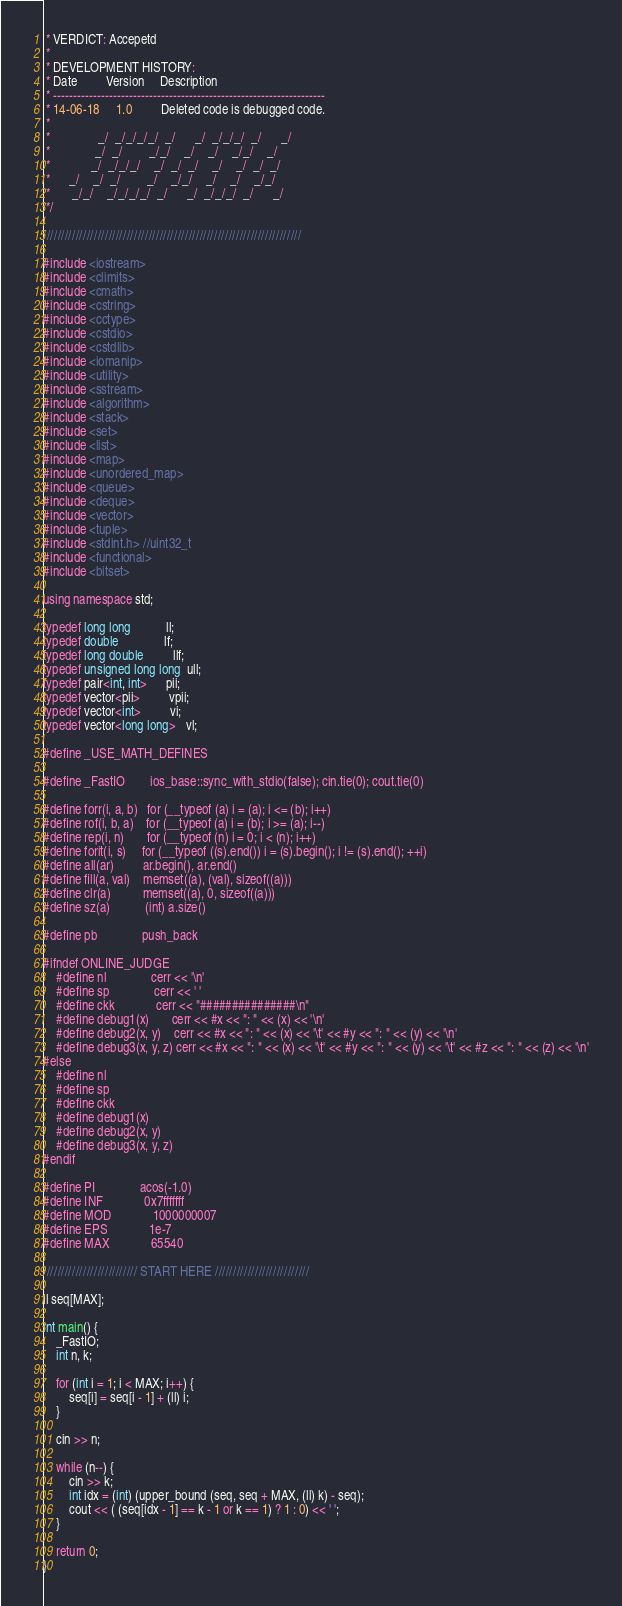<code> <loc_0><loc_0><loc_500><loc_500><_C++_> * VERDICT: Accepetd
 *
 * DEVELOPMENT HISTORY:
 * Date         Version     Description
 * --------------------------------------------------------------------
 * 14-06-18     1.0         Deleted code is debugged code.
 *
 *               _/  _/_/_/_/  _/      _/  _/_/_/  _/      _/
 *              _/  _/        _/_/    _/    _/    _/_/    _/
 *             _/  _/_/_/    _/  _/  _/    _/    _/  _/  _/
 *      _/    _/  _/        _/    _/_/    _/    _/    _/_/
 *       _/_/    _/_/_/_/  _/      _/  _/_/_/  _/      _/
 */

///////////////////////////////////////////////////////////////////////

#include <iostream>
#include <climits>
#include <cmath>
#include <cstring>
#include <cctype>
#include <cstdio>
#include <cstdlib>
#include <iomanip>
#include <utility>
#include <sstream>
#include <algorithm>
#include <stack>
#include <set>
#include <list>
#include <map>
#include <unordered_map>
#include <queue>
#include <deque>
#include <vector>
#include <tuple>
#include <stdint.h> //uint32_t
#include <functional>
#include <bitset>

using namespace std;

typedef long long           ll;
typedef double              lf;
typedef long double         llf;
typedef unsigned long long  ull;
typedef pair<int, int>      pii;
typedef vector<pii>         vpii;
typedef vector<int>         vi;
typedef vector<long long>   vl;

#define _USE_MATH_DEFINES

#define _FastIO        ios_base::sync_with_stdio(false); cin.tie(0); cout.tie(0)

#define forr(i, a, b)   for (__typeof (a) i = (a); i <= (b); i++)
#define rof(i, b, a)    for (__typeof (a) i = (b); i >= (a); i--)
#define rep(i, n)       for (__typeof (n) i = 0; i < (n); i++)
#define forit(i, s)     for (__typeof ((s).end()) i = (s).begin(); i != (s).end(); ++i)
#define all(ar)         ar.begin(), ar.end()
#define fill(a, val)    memset((a), (val), sizeof((a)))
#define clr(a)          memset((a), 0, sizeof((a)))
#define sz(a)           (int) a.size()

#define pb              push_back

#ifndef ONLINE_JUDGE
    #define nl              cerr << '\n'
    #define sp              cerr << ' '
    #define ckk             cerr << "###############\n"
    #define debug1(x)       cerr << #x << ": " << (x) << '\n'
    #define debug2(x, y)    cerr << #x << ": " << (x) << '\t' << #y << ": " << (y) << '\n'
    #define debug3(x, y, z) cerr << #x << ": " << (x) << '\t' << #y << ": " << (y) << '\t' << #z << ": " << (z) << '\n'
#else
    #define nl
    #define sp
    #define ckk
    #define debug1(x)
    #define debug2(x, y)
    #define debug3(x, y, z)
#endif

#define PI              acos(-1.0)
#define INF             0x7fffffff
#define MOD             1000000007
#define EPS             1e-7
#define MAX             65540

////////////////////////// START HERE //////////////////////////

ll seq[MAX];

int main() {
    _FastIO;
    int n, k;

    for (int i = 1; i < MAX; i++) {
        seq[i] = seq[i - 1] + (ll) i;
    }

    cin >> n;

    while (n--) {
        cin >> k;
        int idx = (int) (upper_bound (seq, seq + MAX, (ll) k) - seq);
        cout << ( (seq[idx - 1] == k - 1 or k == 1) ? 1 : 0) << ' ';
    }

    return 0;
}

</code> 